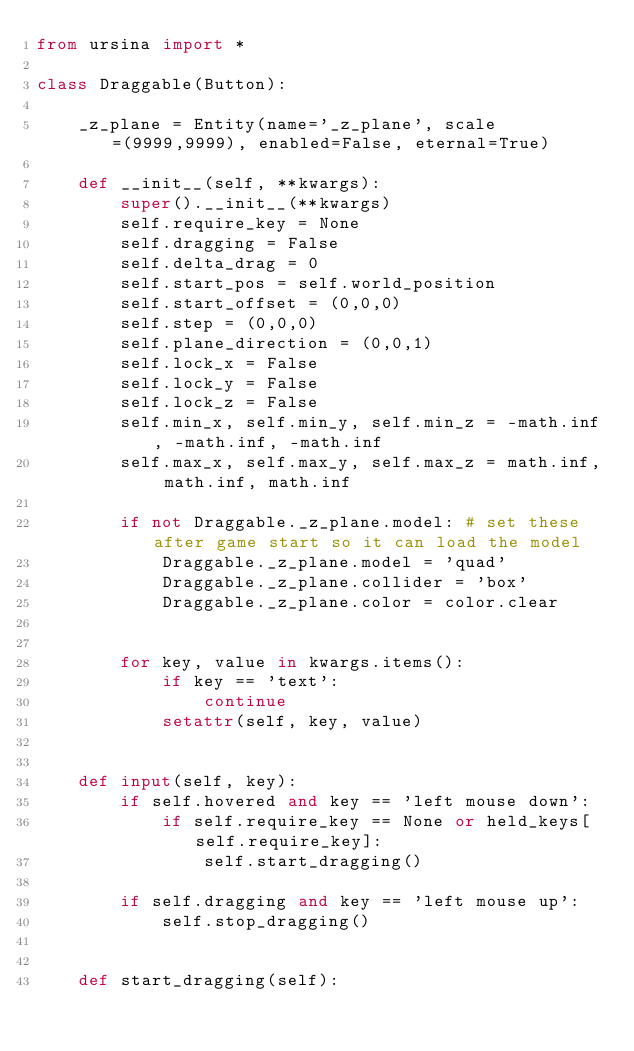<code> <loc_0><loc_0><loc_500><loc_500><_Python_>from ursina import *

class Draggable(Button):

    _z_plane = Entity(name='_z_plane', scale=(9999,9999), enabled=False, eternal=True)

    def __init__(self, **kwargs):
        super().__init__(**kwargs)
        self.require_key = None
        self.dragging = False
        self.delta_drag = 0
        self.start_pos = self.world_position
        self.start_offset = (0,0,0)
        self.step = (0,0,0)
        self.plane_direction = (0,0,1)
        self.lock_x = False
        self.lock_y = False
        self.lock_z = False
        self.min_x, self.min_y, self.min_z = -math.inf, -math.inf, -math.inf
        self.max_x, self.max_y, self.max_z = math.inf, math.inf, math.inf

        if not Draggable._z_plane.model: # set these after game start so it can load the model
            Draggable._z_plane.model = 'quad'
            Draggable._z_plane.collider = 'box'
            Draggable._z_plane.color = color.clear


        for key, value in kwargs.items():
            if key == 'text':
                continue
            setattr(self, key, value)


    def input(self, key):
        if self.hovered and key == 'left mouse down':
            if self.require_key == None or held_keys[self.require_key]:
                self.start_dragging()

        if self.dragging and key == 'left mouse up':
            self.stop_dragging()


    def start_dragging(self):</code> 